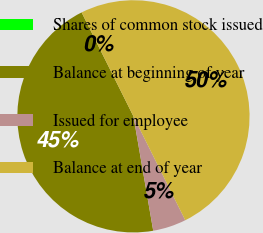Convert chart. <chart><loc_0><loc_0><loc_500><loc_500><pie_chart><fcel>Shares of common stock issued<fcel>Balance at beginning of year<fcel>Issued for employee<fcel>Balance at end of year<nl><fcel>0.0%<fcel>45.36%<fcel>4.64%<fcel>50.0%<nl></chart> 